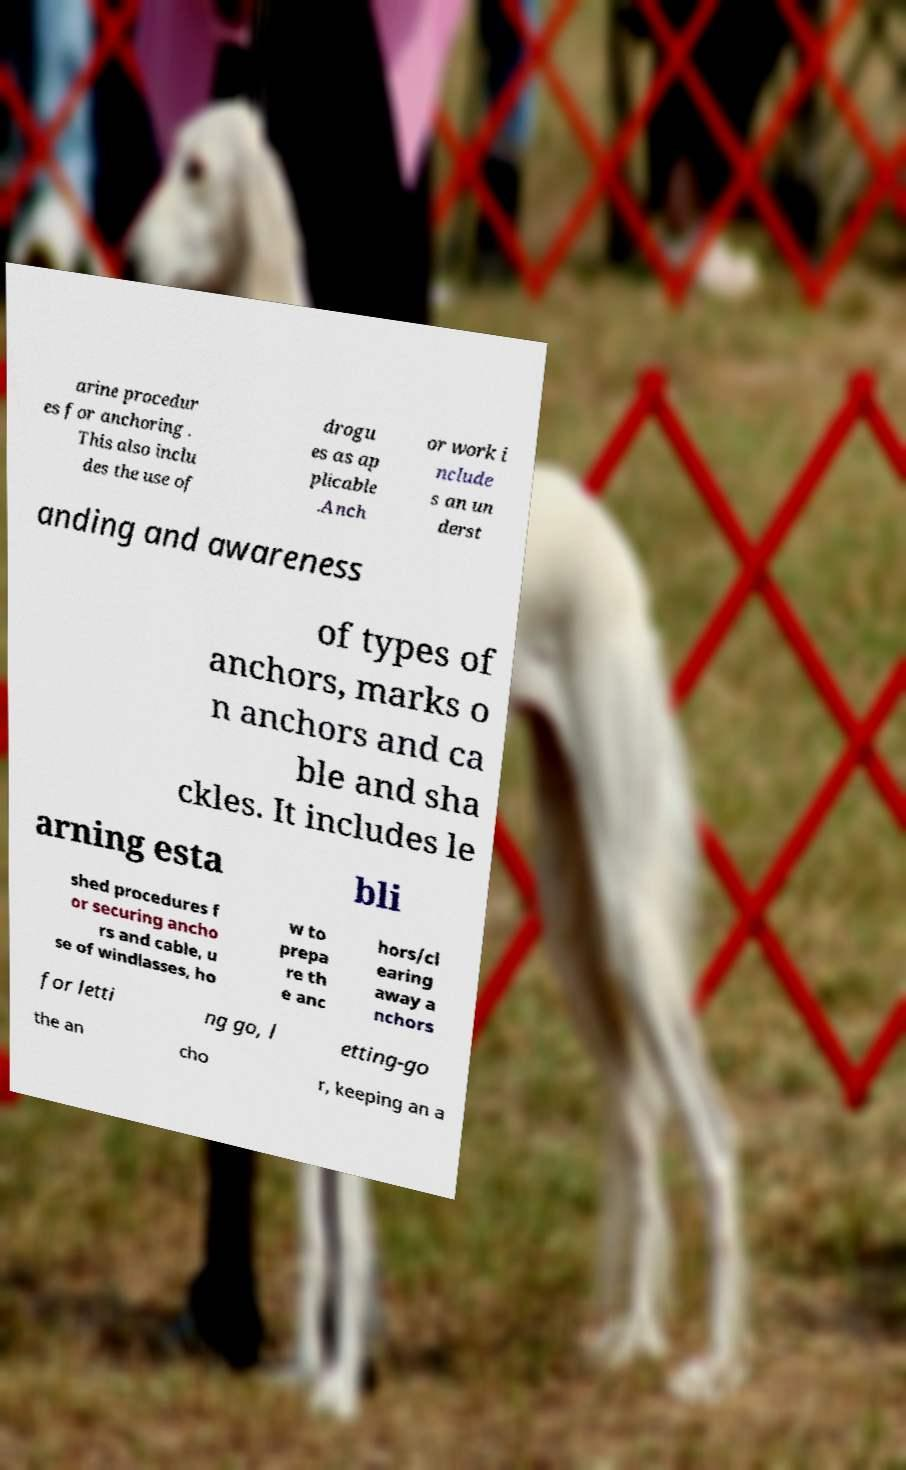Could you extract and type out the text from this image? arine procedur es for anchoring . This also inclu des the use of drogu es as ap plicable .Anch or work i nclude s an un derst anding and awareness of types of anchors, marks o n anchors and ca ble and sha ckles. It includes le arning esta bli shed procedures f or securing ancho rs and cable, u se of windlasses, ho w to prepa re th e anc hors/cl earing away a nchors for letti ng go, l etting-go the an cho r, keeping an a 